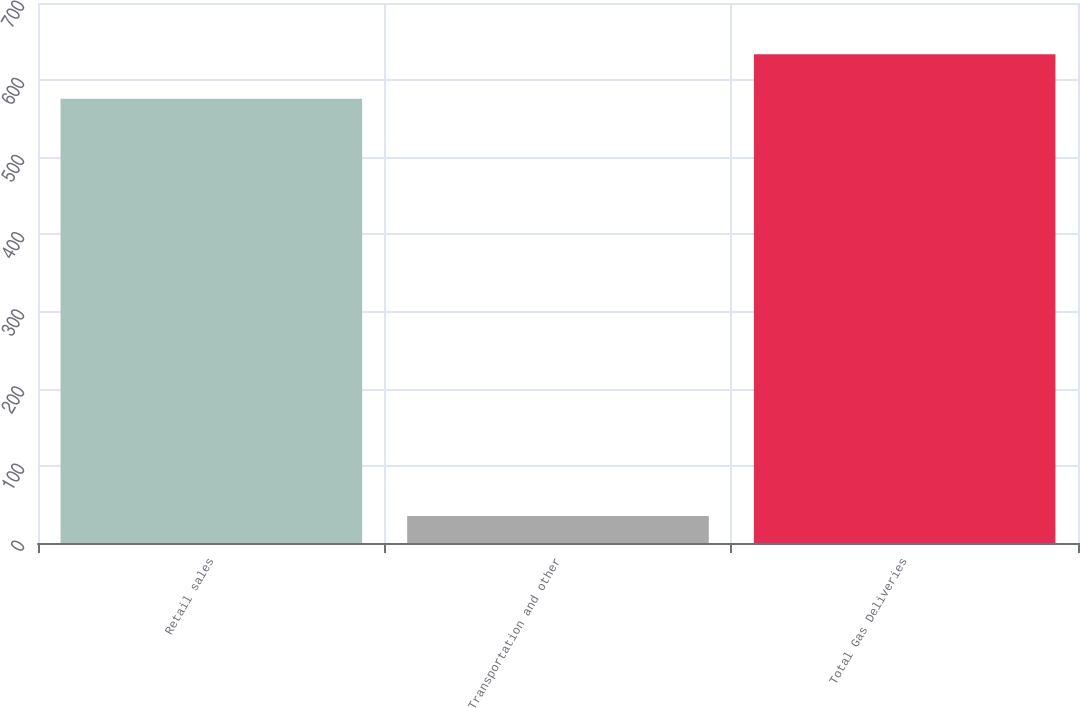Convert chart. <chart><loc_0><loc_0><loc_500><loc_500><bar_chart><fcel>Retail sales<fcel>Transportation and other<fcel>Total Gas Deliveries<nl><fcel>576<fcel>35<fcel>633.6<nl></chart> 